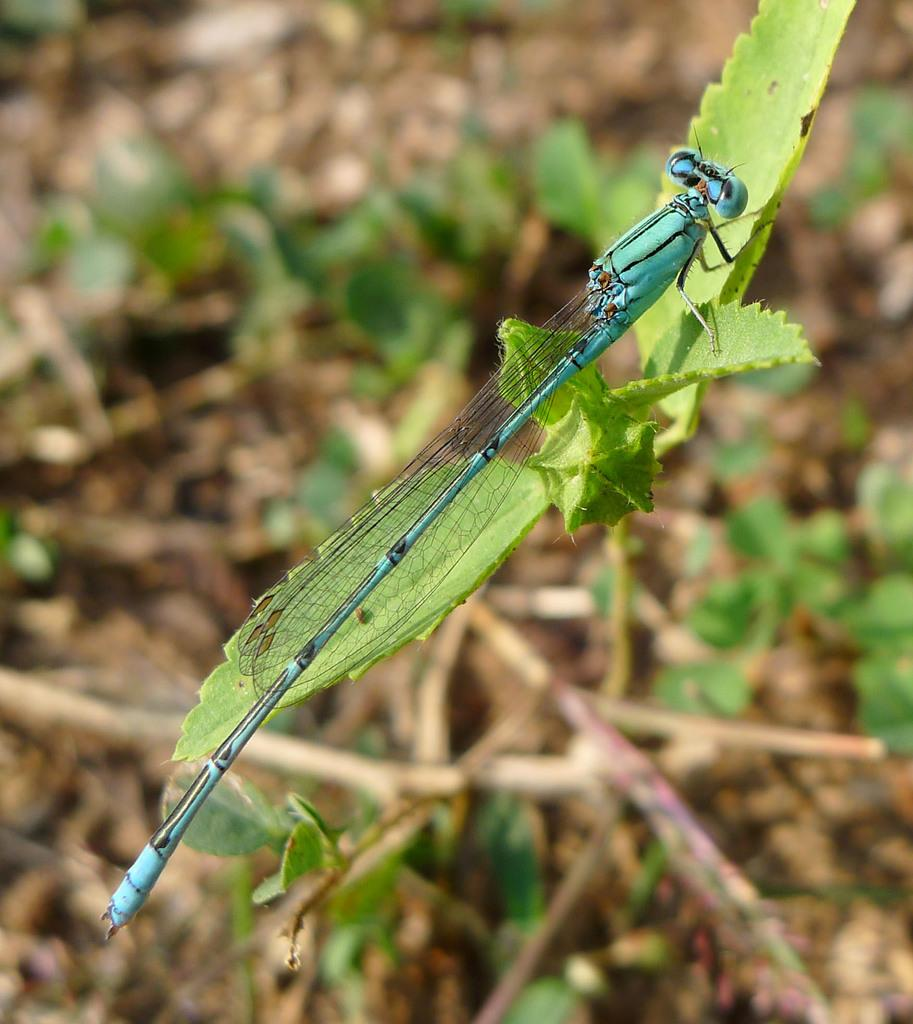What type of creature can be seen in the image? There is an insect in the image. Where is the insect located? The insect is on leaves. What can be seen in the background of the image? There are plants visible in the background of the image. How would you describe the clarity of the image? The image is blurry. What type of grain is being harvested by the yak in the image? There is no yak or grain present in the image; it features an insect on leaves with a background of plants. 